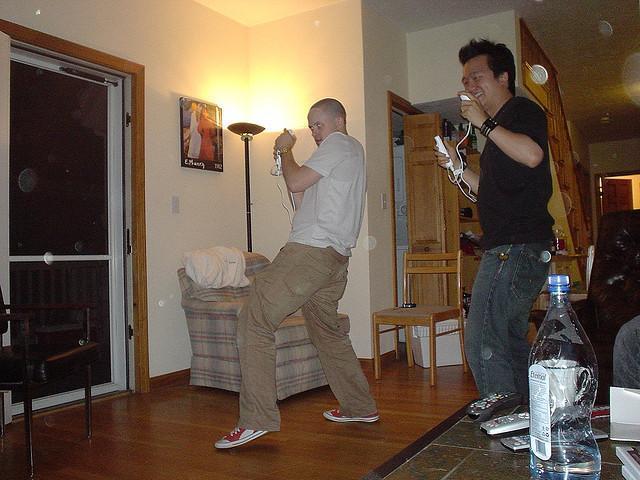How many remote controls are on the table?
Give a very brief answer. 3. How many chairs are in the picture?
Give a very brief answer. 3. How many people can be seen?
Give a very brief answer. 2. 